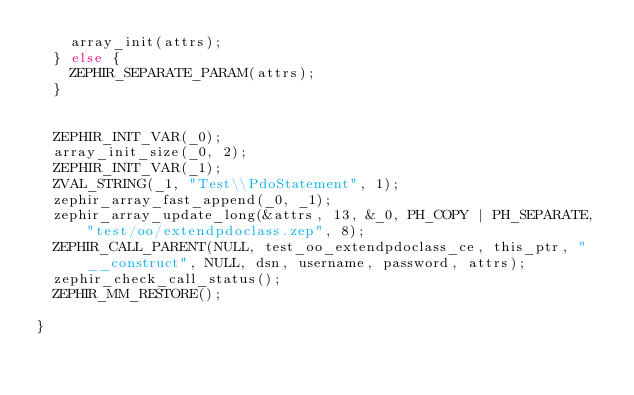Convert code to text. <code><loc_0><loc_0><loc_500><loc_500><_C_>		array_init(attrs);
	} else {
		ZEPHIR_SEPARATE_PARAM(attrs);
	}


	ZEPHIR_INIT_VAR(_0);
	array_init_size(_0, 2);
	ZEPHIR_INIT_VAR(_1);
	ZVAL_STRING(_1, "Test\\PdoStatement", 1);
	zephir_array_fast_append(_0, _1);
	zephir_array_update_long(&attrs, 13, &_0, PH_COPY | PH_SEPARATE, "test/oo/extendpdoclass.zep", 8);
	ZEPHIR_CALL_PARENT(NULL, test_oo_extendpdoclass_ce, this_ptr, "__construct", NULL, dsn, username, password, attrs);
	zephir_check_call_status();
	ZEPHIR_MM_RESTORE();

}

</code> 